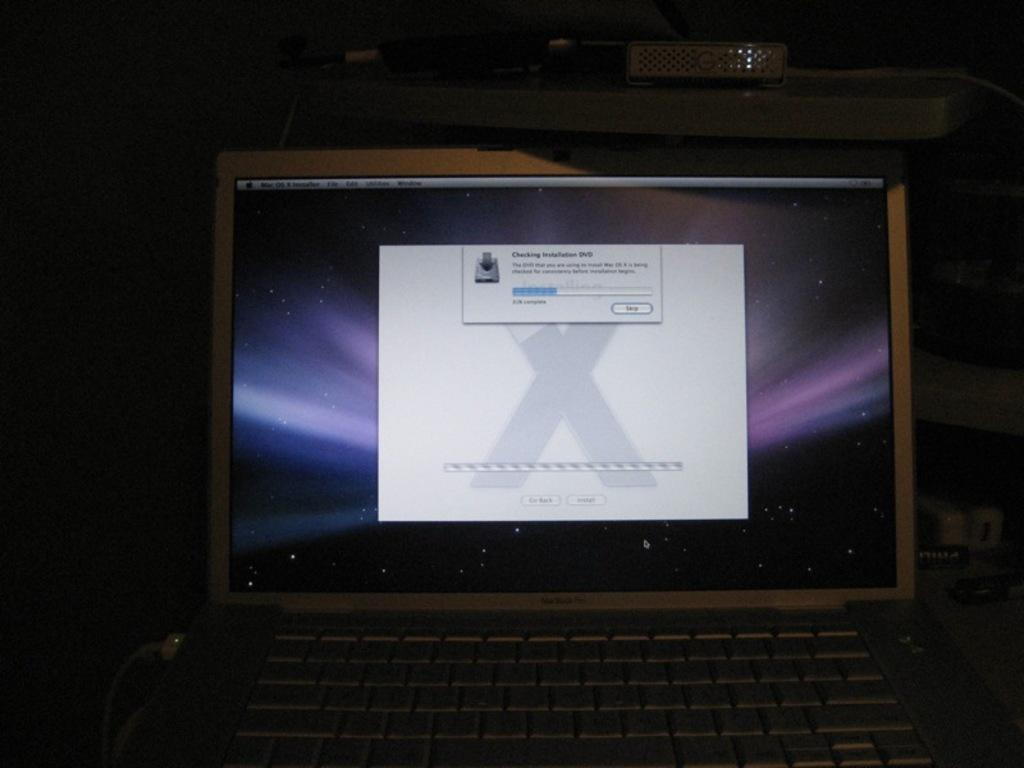<image>
Summarize the visual content of the image. A laptop screen with a open window that says Checking Installation DVD. 